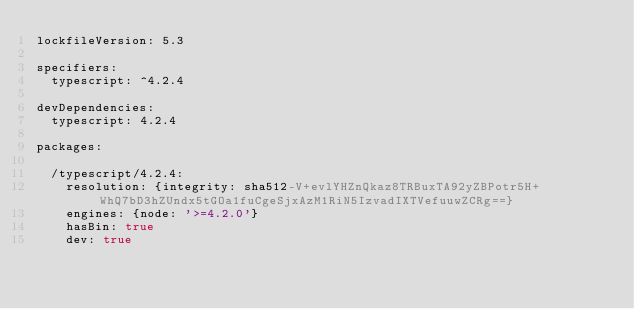Convert code to text. <code><loc_0><loc_0><loc_500><loc_500><_YAML_>lockfileVersion: 5.3

specifiers:
  typescript: ^4.2.4

devDependencies:
  typescript: 4.2.4

packages:

  /typescript/4.2.4:
    resolution: {integrity: sha512-V+evlYHZnQkaz8TRBuxTA92yZBPotr5H+WhQ7bD3hZUndx5tGOa1fuCgeSjxAzM1RiN5IzvadIXTVefuuwZCRg==}
    engines: {node: '>=4.2.0'}
    hasBin: true
    dev: true
</code> 